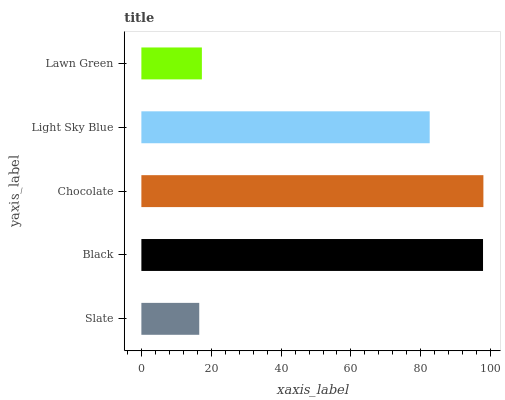Is Slate the minimum?
Answer yes or no. Yes. Is Chocolate the maximum?
Answer yes or no. Yes. Is Black the minimum?
Answer yes or no. No. Is Black the maximum?
Answer yes or no. No. Is Black greater than Slate?
Answer yes or no. Yes. Is Slate less than Black?
Answer yes or no. Yes. Is Slate greater than Black?
Answer yes or no. No. Is Black less than Slate?
Answer yes or no. No. Is Light Sky Blue the high median?
Answer yes or no. Yes. Is Light Sky Blue the low median?
Answer yes or no. Yes. Is Chocolate the high median?
Answer yes or no. No. Is Slate the low median?
Answer yes or no. No. 